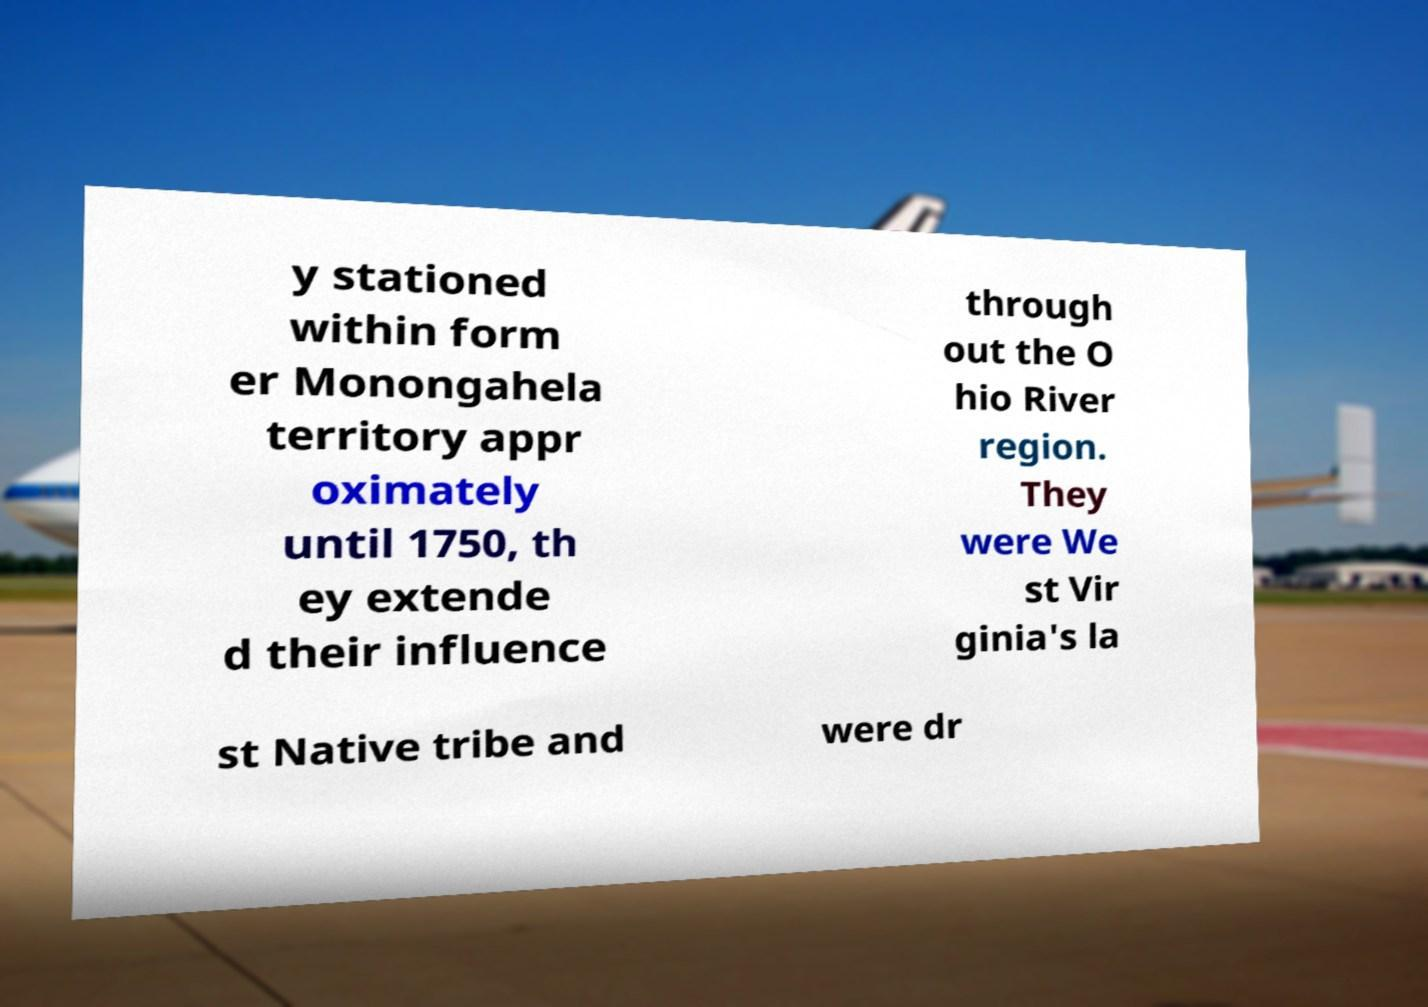Can you read and provide the text displayed in the image?This photo seems to have some interesting text. Can you extract and type it out for me? y stationed within form er Monongahela territory appr oximately until 1750, th ey extende d their influence through out the O hio River region. They were We st Vir ginia's la st Native tribe and were dr 